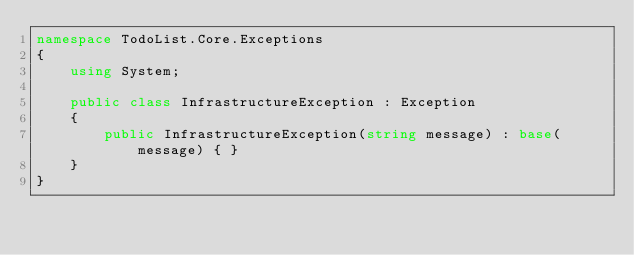Convert code to text. <code><loc_0><loc_0><loc_500><loc_500><_C#_>namespace TodoList.Core.Exceptions
{
    using System;

    public class InfrastructureException : Exception
    {
        public InfrastructureException(string message) : base(message) { }
    }
}</code> 